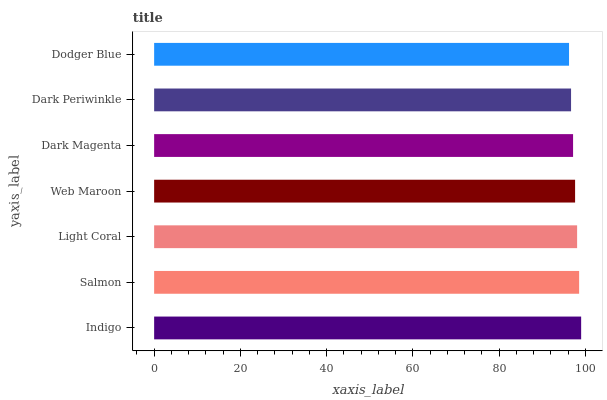Is Dodger Blue the minimum?
Answer yes or no. Yes. Is Indigo the maximum?
Answer yes or no. Yes. Is Salmon the minimum?
Answer yes or no. No. Is Salmon the maximum?
Answer yes or no. No. Is Indigo greater than Salmon?
Answer yes or no. Yes. Is Salmon less than Indigo?
Answer yes or no. Yes. Is Salmon greater than Indigo?
Answer yes or no. No. Is Indigo less than Salmon?
Answer yes or no. No. Is Web Maroon the high median?
Answer yes or no. Yes. Is Web Maroon the low median?
Answer yes or no. Yes. Is Indigo the high median?
Answer yes or no. No. Is Light Coral the low median?
Answer yes or no. No. 